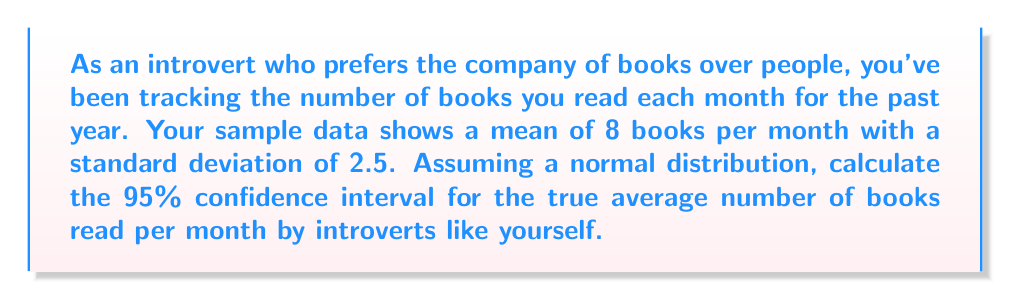Help me with this question. Let's approach this step-by-step:

1) We're given:
   - Sample mean ($\bar{x}$) = 8 books
   - Sample standard deviation (s) = 2.5 books
   - Sample size (n) = 12 (12 months in a year)
   - Confidence level = 95%

2) For a 95% confidence interval, we use a z-score of 1.96.

3) The formula for the confidence interval is:

   $$\bar{x} \pm z \cdot \frac{s}{\sqrt{n}}$$

4) Let's calculate the standard error:
   $$SE = \frac{s}{\sqrt{n}} = \frac{2.5}{\sqrt{12}} \approx 0.7217$$

5) Now, let's calculate the margin of error:
   $$ME = z \cdot SE = 1.96 \cdot 0.7217 \approx 1.4145$$

6) Finally, we can calculate the confidence interval:
   Lower bound: $8 - 1.4145 = 6.5855$
   Upper bound: $8 + 1.4145 = 9.4145$

7) Rounding to one decimal place for practicality:
   The 95% confidence interval is (6.6, 9.4) books per month.
Answer: (6.6, 9.4) books per month 